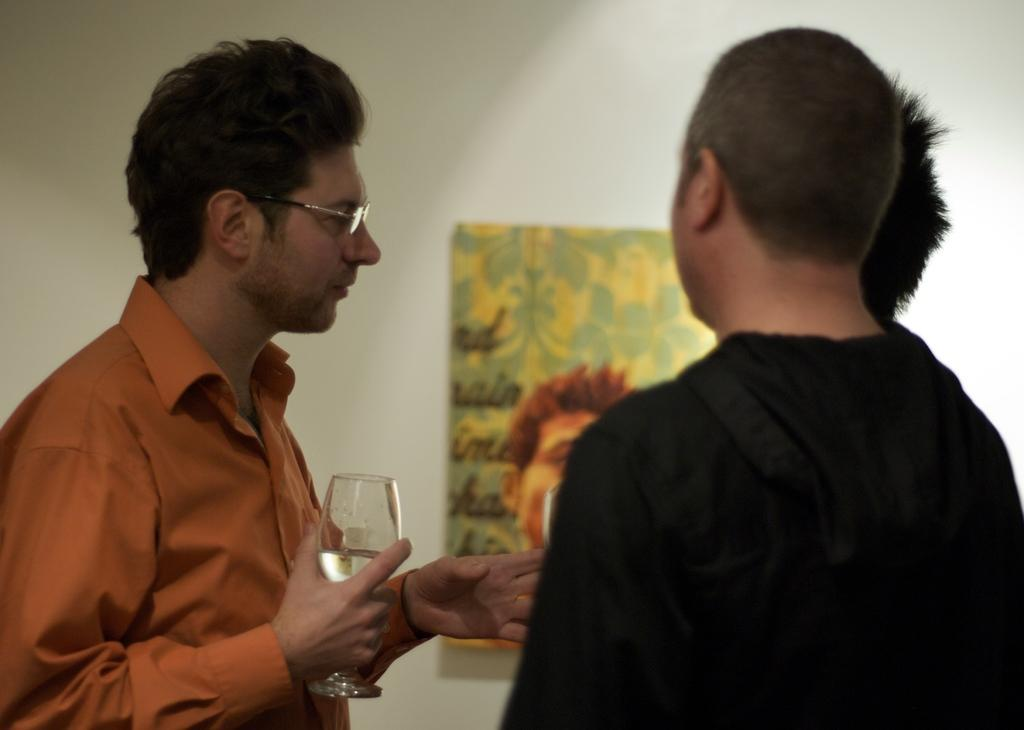What is the position of the person in the image? There is a person standing on the left side of the image. What is the person holding in his hand? The person is holding a glass of wine in his hand. How many other people are present in the image? There are two other people standing in front of the person on the left. What can be seen on the wall in the image? There is a picture on the wall in the image. What type of dolls are sitting on the railway tracks in the image? There are no dolls or railway tracks present in the image. 